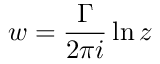Convert formula to latex. <formula><loc_0><loc_0><loc_500><loc_500>w = { \frac { \Gamma } { 2 \pi i } } \ln z</formula> 